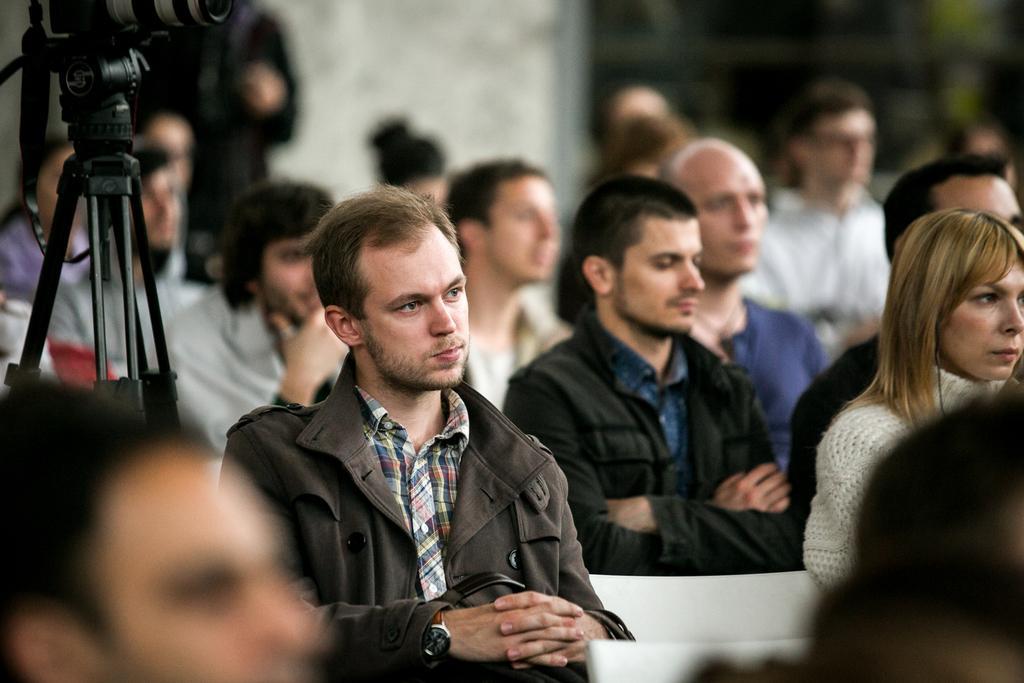Could you give a brief overview of what you see in this image? In this picture I can see group of people sitting on the chairs. I can see a camera with a tripod stand, and there is blur background. 